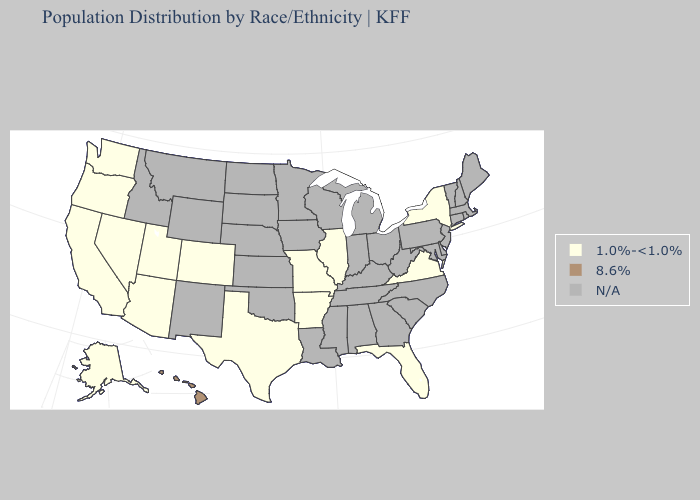What is the highest value in the MidWest ?
Short answer required. 1.0%-<1.0%. Name the states that have a value in the range N/A?
Give a very brief answer. Alabama, Connecticut, Delaware, Georgia, Idaho, Indiana, Iowa, Kansas, Kentucky, Louisiana, Maine, Maryland, Massachusetts, Michigan, Minnesota, Mississippi, Montana, Nebraska, New Hampshire, New Jersey, New Mexico, North Carolina, North Dakota, Ohio, Oklahoma, Pennsylvania, Rhode Island, South Carolina, South Dakota, Tennessee, Vermont, West Virginia, Wisconsin, Wyoming. Which states have the lowest value in the South?
Give a very brief answer. Arkansas, Florida, Texas, Virginia. Which states hav the highest value in the MidWest?
Concise answer only. Illinois, Missouri. Does the map have missing data?
Answer briefly. Yes. Name the states that have a value in the range 1.0%-<1.0%?
Short answer required. Alaska, Arizona, Arkansas, California, Colorado, Florida, Illinois, Missouri, Nevada, New York, Oregon, Texas, Utah, Virginia, Washington. What is the highest value in the USA?
Short answer required. 8.6%. Name the states that have a value in the range 1.0%-<1.0%?
Give a very brief answer. Alaska, Arizona, Arkansas, California, Colorado, Florida, Illinois, Missouri, Nevada, New York, Oregon, Texas, Utah, Virginia, Washington. Does Hawaii have the lowest value in the USA?
Be succinct. No. Among the states that border Arizona , which have the highest value?
Short answer required. California, Colorado, Nevada, Utah. 